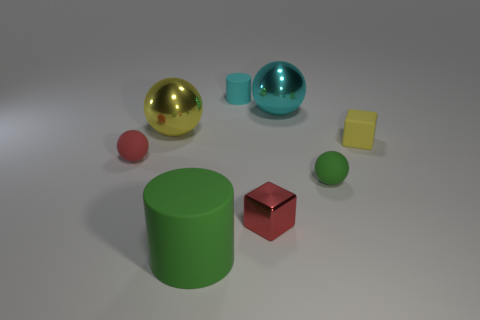Subtract all green rubber balls. How many balls are left? 3 Subtract all red cubes. How many cubes are left? 1 Subtract all cylinders. How many objects are left? 6 Subtract all tiny red spheres. Subtract all small spheres. How many objects are left? 5 Add 1 big cyan shiny balls. How many big cyan shiny balls are left? 2 Add 2 metal balls. How many metal balls exist? 4 Add 1 rubber things. How many objects exist? 9 Subtract 1 red balls. How many objects are left? 7 Subtract 1 blocks. How many blocks are left? 1 Subtract all red cubes. Subtract all red cylinders. How many cubes are left? 1 